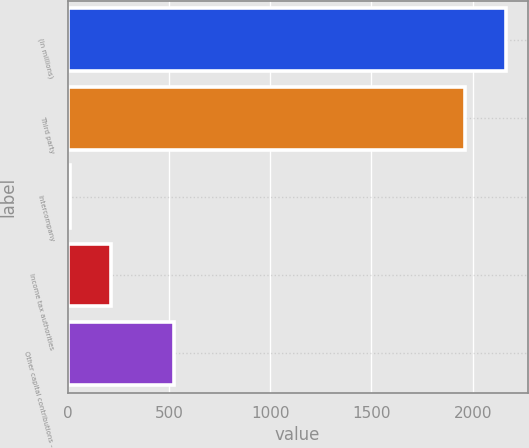<chart> <loc_0><loc_0><loc_500><loc_500><bar_chart><fcel>(in millions)<fcel>Third party<fcel>Intercompany<fcel>Income tax authorities<fcel>Other capital contributions -<nl><fcel>2163.1<fcel>1963<fcel>12<fcel>212.1<fcel>523<nl></chart> 